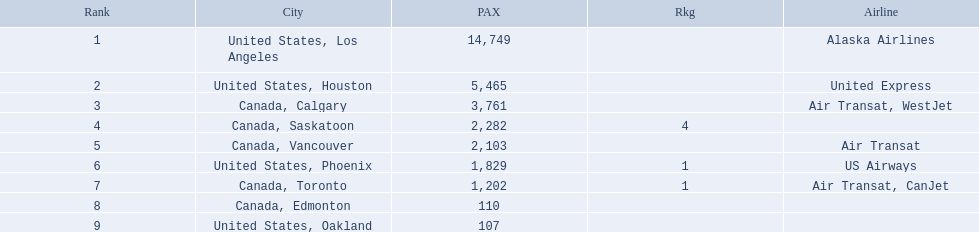What are the cities that are associated with the playa de oro international airport? United States, Los Angeles, United States, Houston, Canada, Calgary, Canada, Saskatoon, Canada, Vancouver, United States, Phoenix, Canada, Toronto, Canada, Edmonton, United States, Oakland. What is uniteed states, los angeles passenger count? 14,749. What other cities passenger count would lead to 19,000 roughly when combined with previous los angeles? Canada, Calgary. 